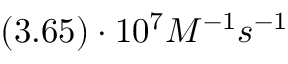<formula> <loc_0><loc_0><loc_500><loc_500>( 3 . 6 5 ) \cdot 1 0 ^ { 7 } M ^ { - 1 } s ^ { - 1 }</formula> 